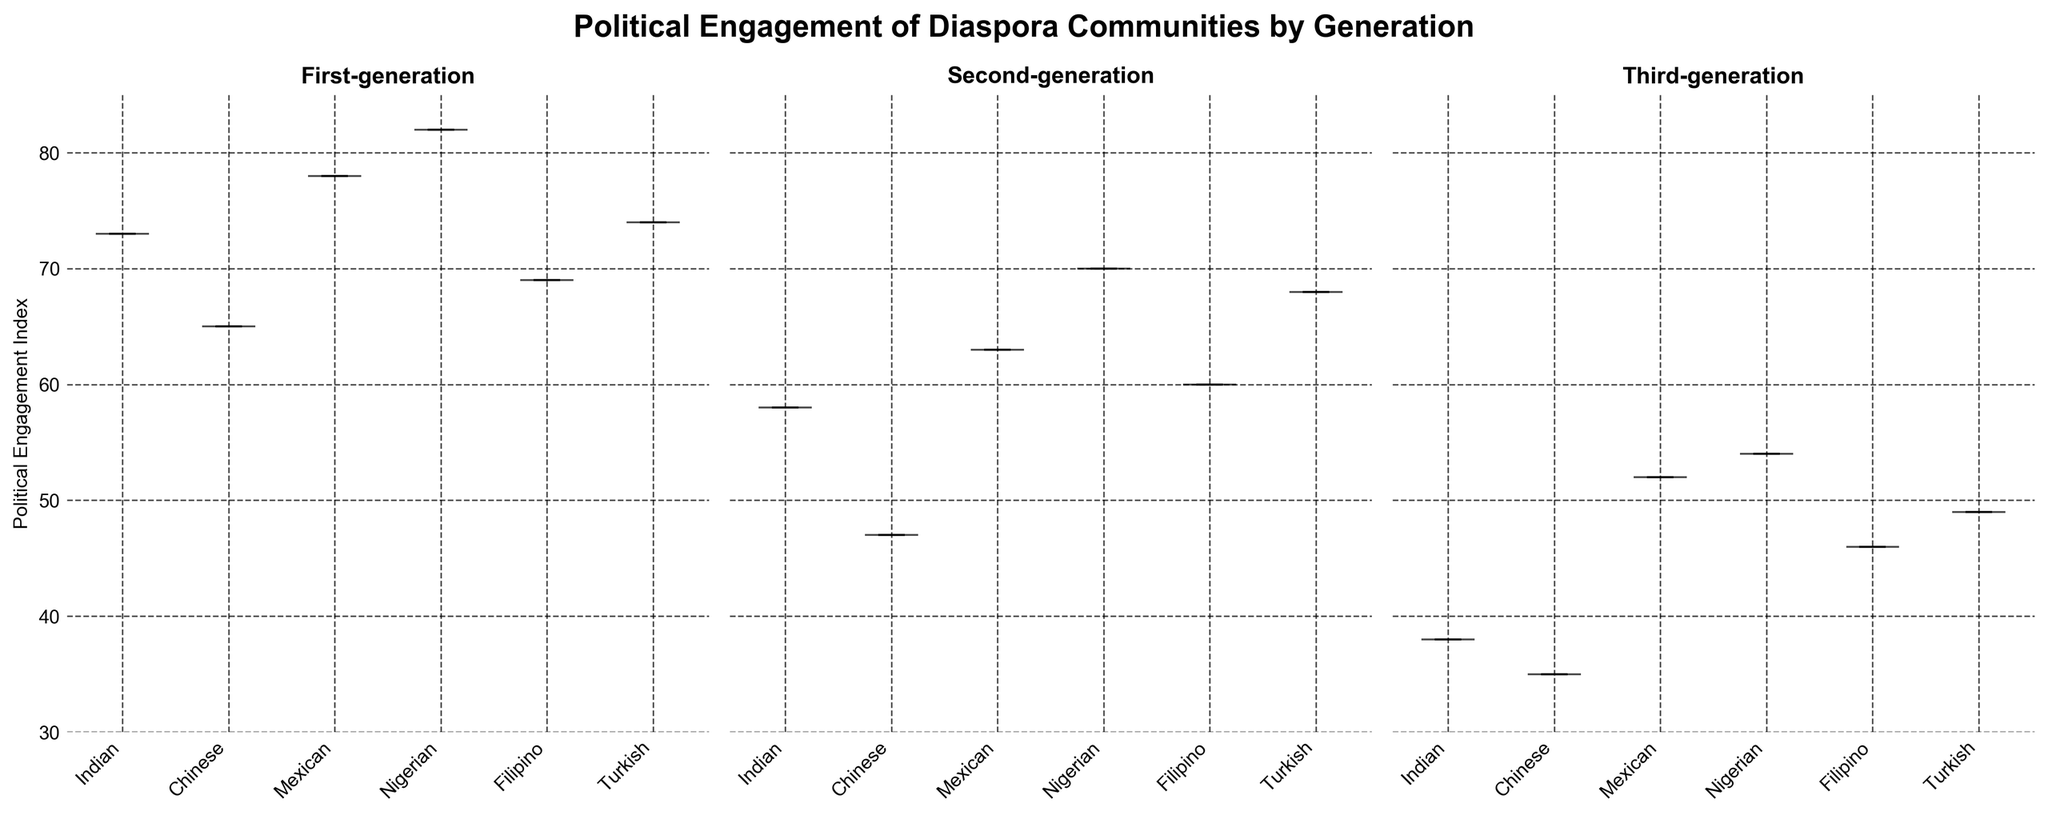What is the overall title of the figure? The overall title is written at the top of the figure and summarizes what the entire figure is about.
Answer: Political Engagement of Diaspora Communities by Generation Which generation has the highest median Political Engagement Index? Each subplot (violin plot) has a median line which can be compared. The generation with the highest median line has the highest median Political Engagement Index.
Answer: First-generation How many different diaspora communities are represented in each subplot? Each subplot represents data for different diaspora communities, and the x-axis label shows the diaspora community names. Count the number of labels.
Answer: 6 Which diaspora community has the highest political engagement in the first-generation group? Examine the first subplot and find the violin plot with the highest point. The highest point indicates the highest individual index for that diaspora community.
Answer: Nigerian What is the approximate range of the Political Engagement Index for the second-generation Indian diaspora community? Look at the width of the violin plot for the second-generation Indian community in the second subplot. The top and bottom ends of the plot provide the approximate range.
Answer: 50-60 Compare the median Political Engagement Index between the Chinese community in first-generation and second-generation groups. Which is higher? Locate the median line within the Chinese community's violin plot in both the first- and second-generation subplots. Compare the height of these lines.
Answer: First-generation Which plot shows the greatest variety in Political Engagement Index across diaspora communities, and how can you tell? The variety is indicated by the spread and shapes of the violin plots. A wider spread indicates greater variety. Observe the spread for each generation's subplot.
Answer: First-generation; wider spread What trend can you observe in the Political Engagement Index from the first to the third generation for the Mexican diaspora community? Look at the violin plots for the Mexican community in all three subplots. Find the change in the median line or the overall shape from one generation to the next.
Answer: Decreasing Which diaspora community in Germany has the narrowest range of Political Engagement Index in any generation, and which generation is it? Find the violin plot for the Turkish community in Germany, then compare the spread (width) of this plot across all three generations. The narrowest plot shows the narrowest range.
Answer: Third-generation 